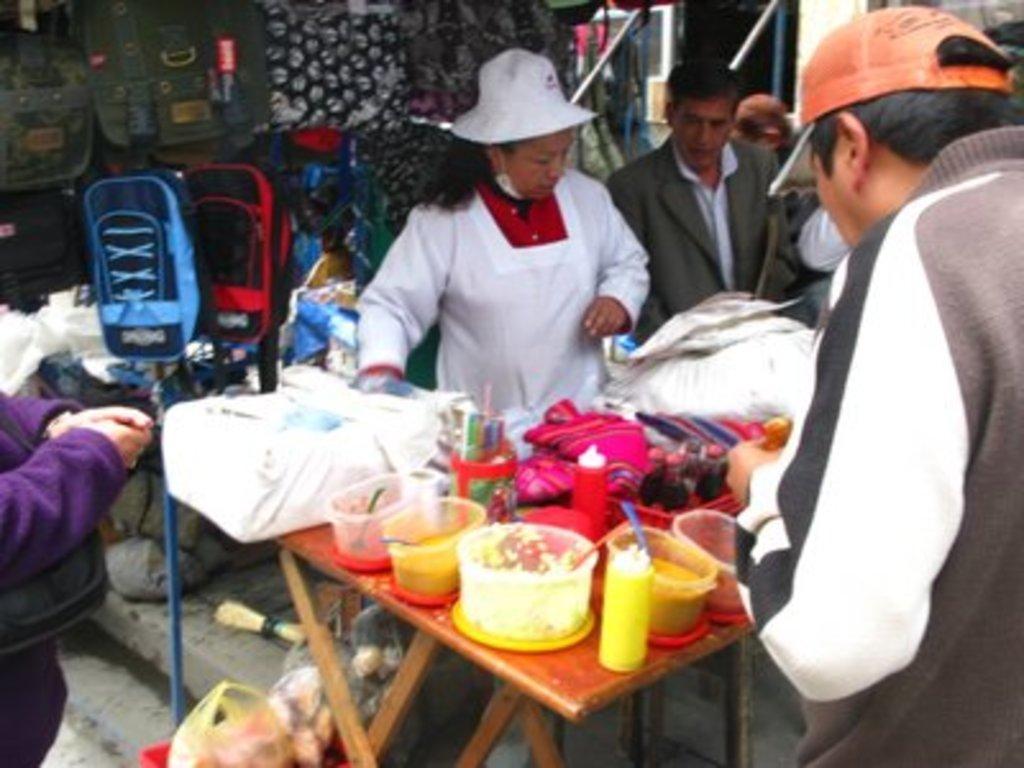Describe this image in one or two sentences. In this image we can see a group of people standing. In that a man wearing a cap is holding some food and the woman is wearing a hat. We can also see a table beside them containing some bowls with spoons inside it, bottles, a jar and some clothes on it. We can also see some covers and a broom on the ground. On the backside we can see some clothes and bags to the stand. 